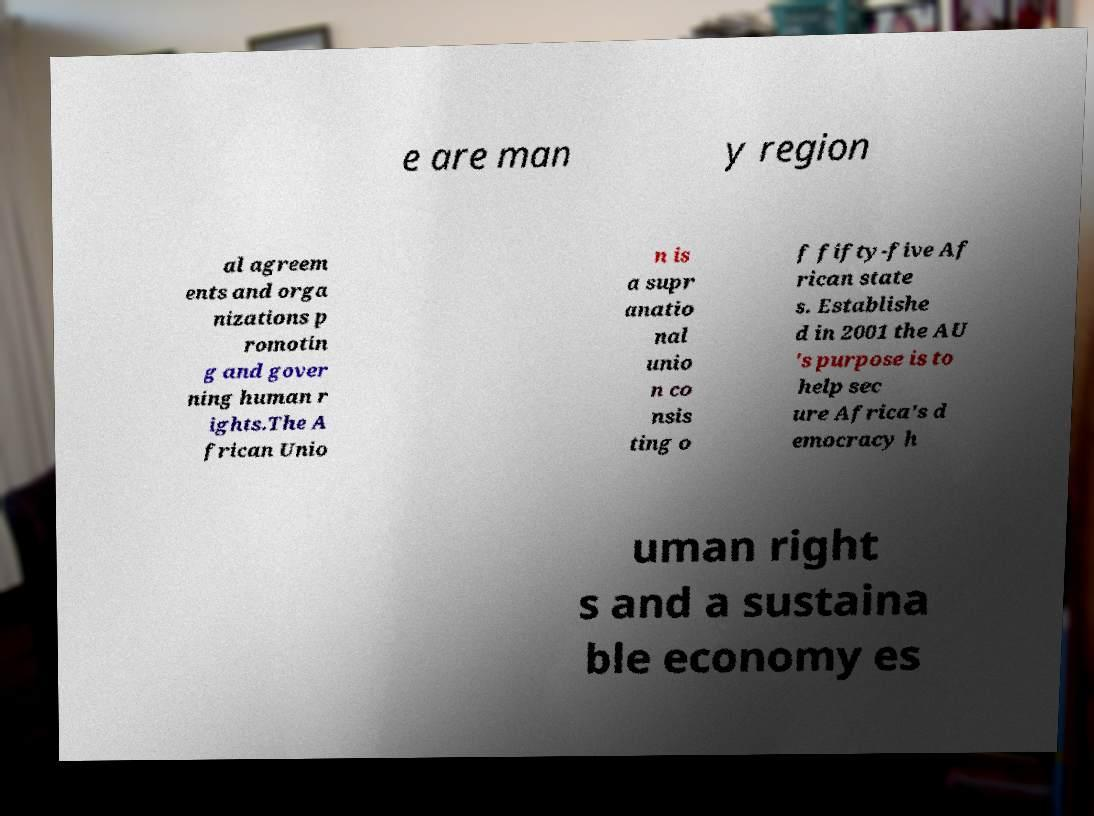Please read and relay the text visible in this image. What does it say? e are man y region al agreem ents and orga nizations p romotin g and gover ning human r ights.The A frican Unio n is a supr anatio nal unio n co nsis ting o f fifty-five Af rican state s. Establishe d in 2001 the AU 's purpose is to help sec ure Africa's d emocracy h uman right s and a sustaina ble economy es 